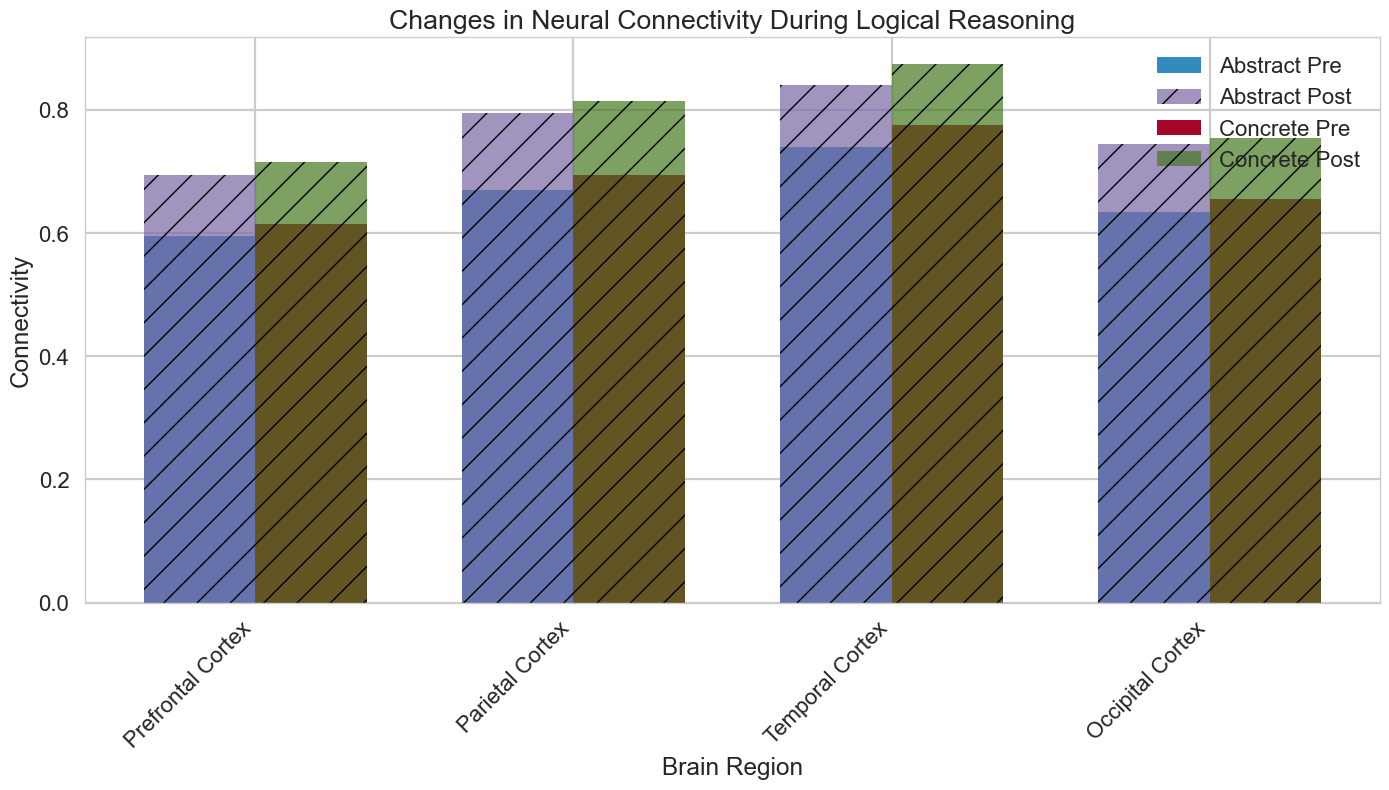What is the average post-connectivity value for the Prefrontal Cortex in both abstract and concrete reasoning? First, find the post-connectivity values for the Prefrontal Cortex: for abstract reasoning, it is 0.85 and 0.83; for concrete reasoning, it is 0.88 and 0.87. Calculate the average for abstract reasoning: (0.85 + 0.83) / 2 = 0.84. Calculate the average for concrete reasoning: (0.88 + 0.87) / 2 = 0.875.
Answer: Abstract: 0.84, Concrete: 0.875 Which brain region shows the highest increase in connectivity for concrete reasoning? Start by finding the pre and post connectivity values for each region for concrete reasoning: Prefrontal Cortex (0.78 to 0.88 and 0.77 to 0.87), Parietal Cortex (0.70 to 0.82 and 0.69 to 0.81), Temporal Cortex (0.66 to 0.76 and 0.65 to 0.75), Occipital Cortex (0.62 to 0.72 and 0.61 to 0.71). Calculate the differences: Prefrontal Cortex = (0.88 - 0.78) + (0.87 - 0.77) = 0.1 + 0.1 = 0.2, Parietal Cortex = (0.82 - 0.70) + (0.81 - 0.69) = 0.12 + 0.12 = 0.24, Temporal Cortex = (0.76 - 0.66) + (0.75 - 0.65) = 0.1 + 0.1 = 0.2, Occipital Cortex = (0.72 - 0.62) + (0.71 - 0.61) = 0.1 + 0.1 = 0.2. The highest increase is in the Parietal Cortex (0.24).
Answer: Parietal Cortex How does the increase in connectivity for abstract reasoning compare between the Prefrontal Cortex and the Temporal Cortex? Compare the pre and post values for the Prefrontal Cortex: (0.85 - 0.75) + (0.83 - 0.73) = 0.1 + 0.1 = 0.2. For the Temporal Cortex: (0.75 - 0.64) + (0.74 - 0.63) = 0.11 + 0.11 = 0.22. The increase in connectivity is higher for the Temporal Cortex.
Answer: Temporal Cortex has a higher increase Is there any brain region where the pre-connectivity value of concrete reasoning is higher than the post-connectivity value of abstract reasoning? For each region, compare pre-connectivity of concrete reasoning and post-connectivity of abstract reasoning: 
- Prefrontal Cortex: pre = 0.78, 0.77 vs post = 0.85, 0.83
- Parietal Cortex: pre = 0.70, 0.69 vs post = 0.80, 0.79
- Temporal Cortex: pre = 0.66, 0.65 vs post = 0.75, 0.74
- Occipital Cortex: pre = 0.62, 0.61 vs post = 0.70, 0.69.
No pre-connectivity value for concrete reasoning is higher than the post-connectivity value for abstract reasoning in any region.
Answer: No Which reasoning type shows a greater increase in connectivity overall? Calculate the average increase for each reasoning type across all regions. For abstract: (0.85 - 0.75) + (0.83 - 0.73) + (0.80 - 0.68) + (0.79 - 0.66) + (0.75 - 0.64) + (0.74 - 0.63) + (0.70 - 0.60) + (0.69 - 0.59) = 0.1 + 0.1 + 0.12 + 0.13 + 0.11 + 0.11 + 0.1 + 0.1 = 0.97 / 8 = 0.12125. For concrete: (0.88 - 0.78) + (0.87 - 0.77) + (0.82 - 0.70) + (0.81 - 0.69) + (0.76 - 0.66) + (0.75 - 0.65) + (0.72 - 0.62) + (0.71 - 0.61) = 0.1 + 0.1 + 0.12 + 0.12 + 0.1 + 0.1 + 0.1 + 0.1 = 0.94 / 8 = 0.1175. Overall, abstract reasoning shows a greater increase in connectivity.
Answer: Abstract reasoning 